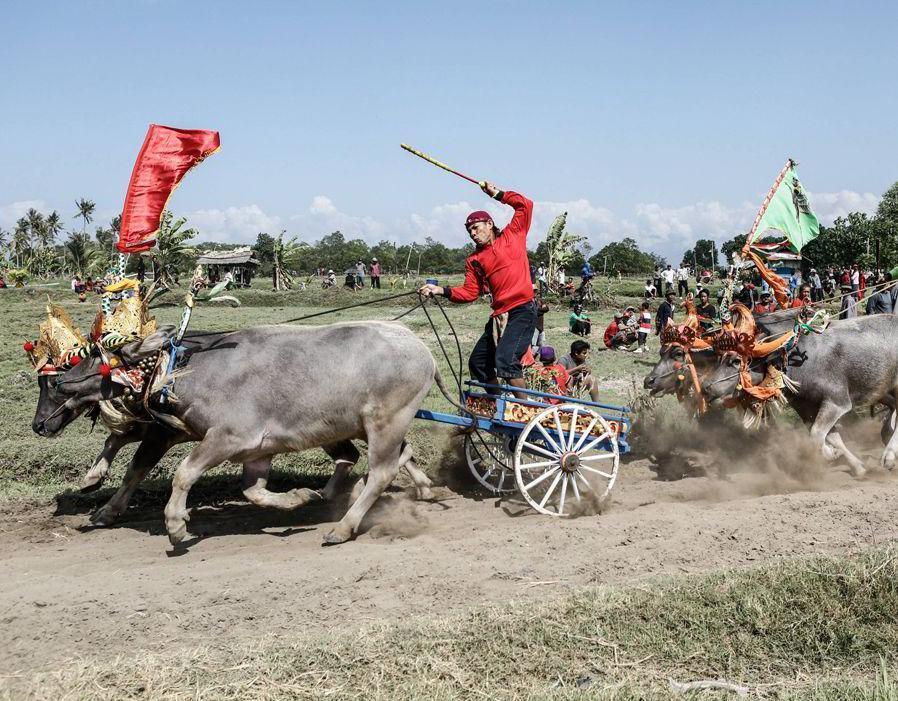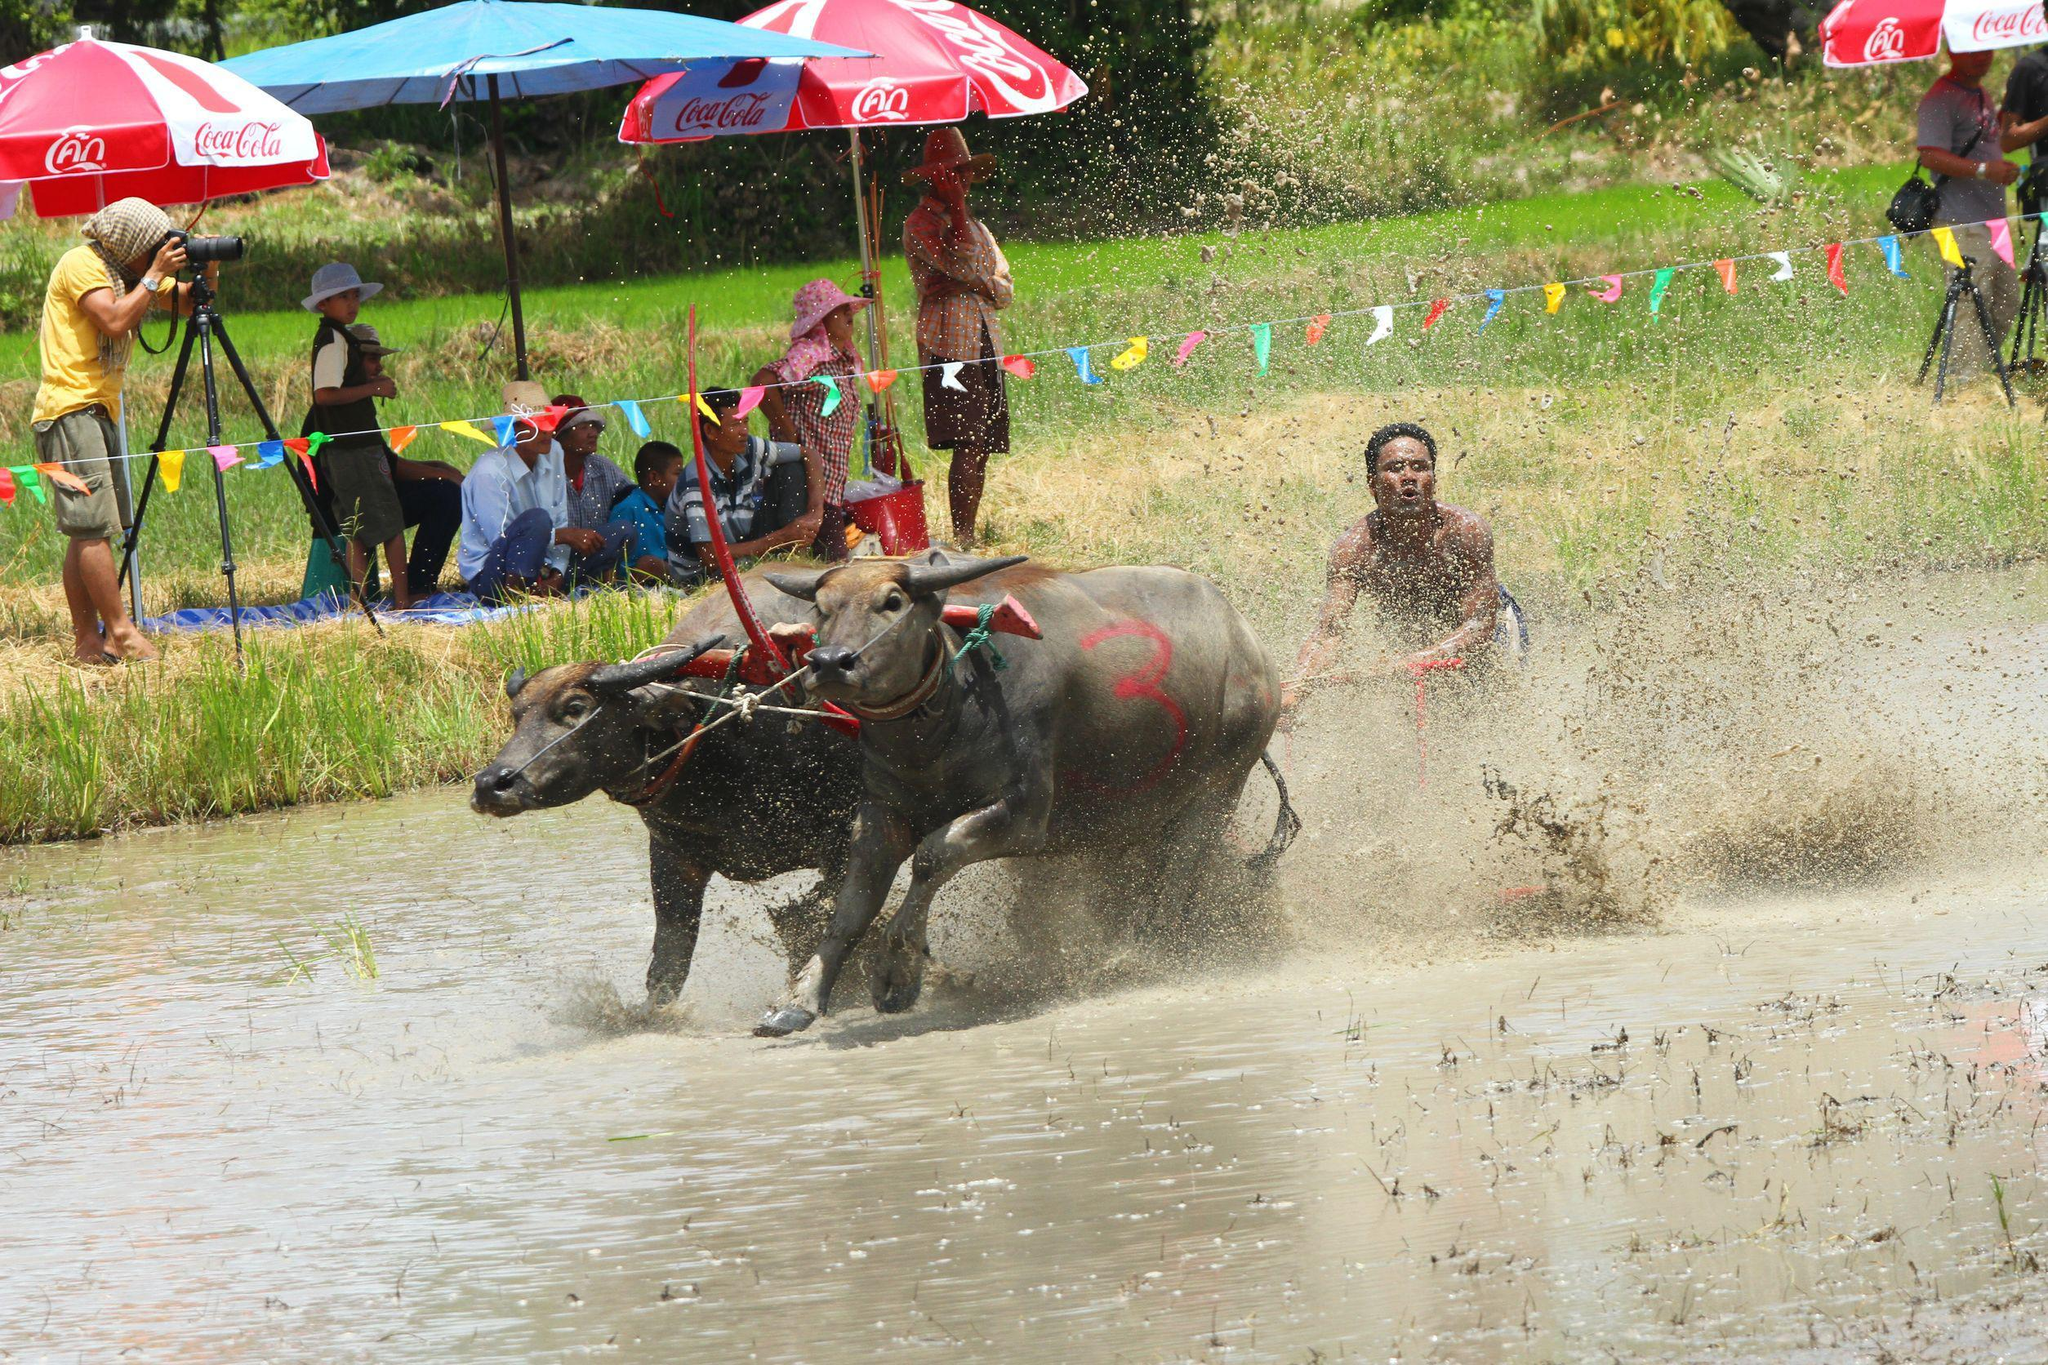The first image is the image on the left, the second image is the image on the right. Assess this claim about the two images: "An umbrella hovers over the cart in one of the images.". Correct or not? Answer yes or no. No. 